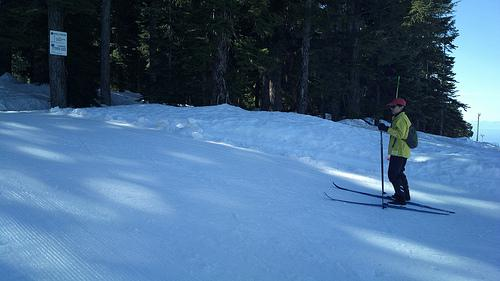Question: who is in this picture?
Choices:
A. A skier.
B. Mother.
C. A shopper.
D. A gymnast.
Answer with the letter. Answer: A Question: where are the skis?
Choices:
A. On the skier's feet.
B. On the car.
C. On the floor.
D. On the bench.
Answer with the letter. Answer: A Question: what is on the ground?
Choices:
A. Grass.
B. Dirt.
C. Rocks.
D. Snow.
Answer with the letter. Answer: D Question: what color is the sky?
Choices:
A. Pink.
B. Gray.
C. Yellow.
D. Blue.
Answer with the letter. Answer: D Question: what is on the skier's head?
Choices:
A. A Helmet.
B. A hat.
C. Goggles.
D. Mask.
Answer with the letter. Answer: B Question: what color are the trees?
Choices:
A. Brown.
B. Green.
C. Yellow.
D. Red.
Answer with the letter. Answer: B 